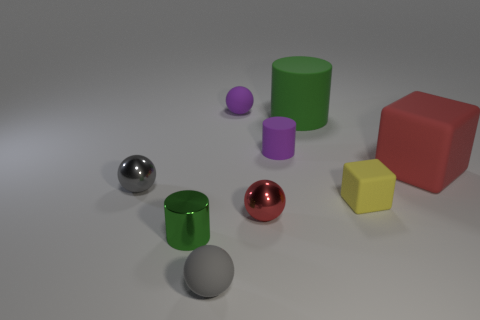Subtract all red balls. How many balls are left? 3 Subtract all yellow spheres. Subtract all cyan blocks. How many spheres are left? 4 Subtract all cubes. How many objects are left? 7 Add 5 tiny red shiny balls. How many tiny red shiny balls are left? 6 Add 2 red shiny objects. How many red shiny objects exist? 3 Subtract 0 cyan cylinders. How many objects are left? 9 Subtract all small matte objects. Subtract all tiny purple cylinders. How many objects are left? 4 